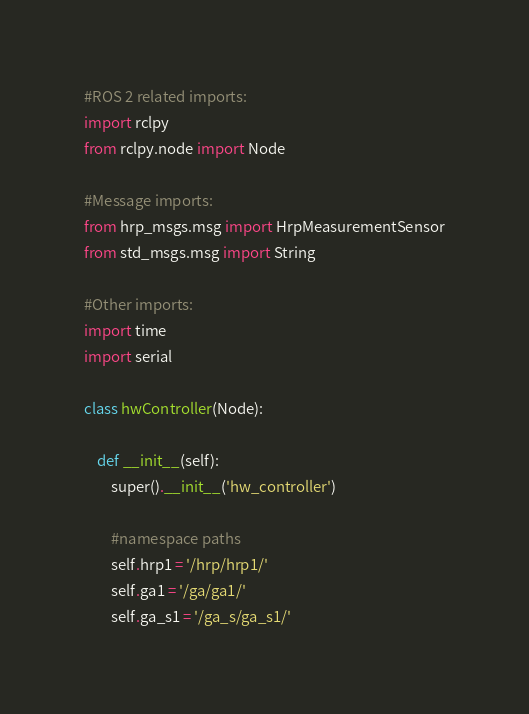Convert code to text. <code><loc_0><loc_0><loc_500><loc_500><_Python_>#ROS 2 related imports:
import rclpy
from rclpy.node import Node

#Message imports:
from hrp_msgs.msg import HrpMeasurementSensor
from std_msgs.msg import String

#Other imports:
import time
import serial

class hwController(Node):

    def __init__(self):
        super().__init__('hw_controller')

        #namespace paths
        self.hrp1 = '/hrp/hrp1/'
        self.ga1 = '/ga/ga1/'
        self.ga_s1 = '/ga_s/ga_s1/'</code> 